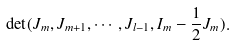<formula> <loc_0><loc_0><loc_500><loc_500>\det ( J _ { m } , J _ { m + 1 } , \cdots , J _ { l - 1 } , I _ { m } - \frac { 1 } { 2 } J _ { m } ) .</formula> 